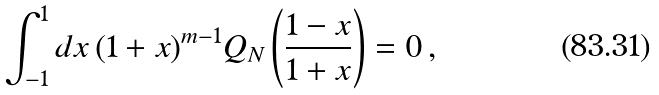Convert formula to latex. <formula><loc_0><loc_0><loc_500><loc_500>\int _ { - 1 } ^ { 1 } d x \, ( 1 + x ) ^ { m - 1 } Q _ { N } \left ( \frac { 1 - x } { 1 + x } \right ) = 0 \, ,</formula> 